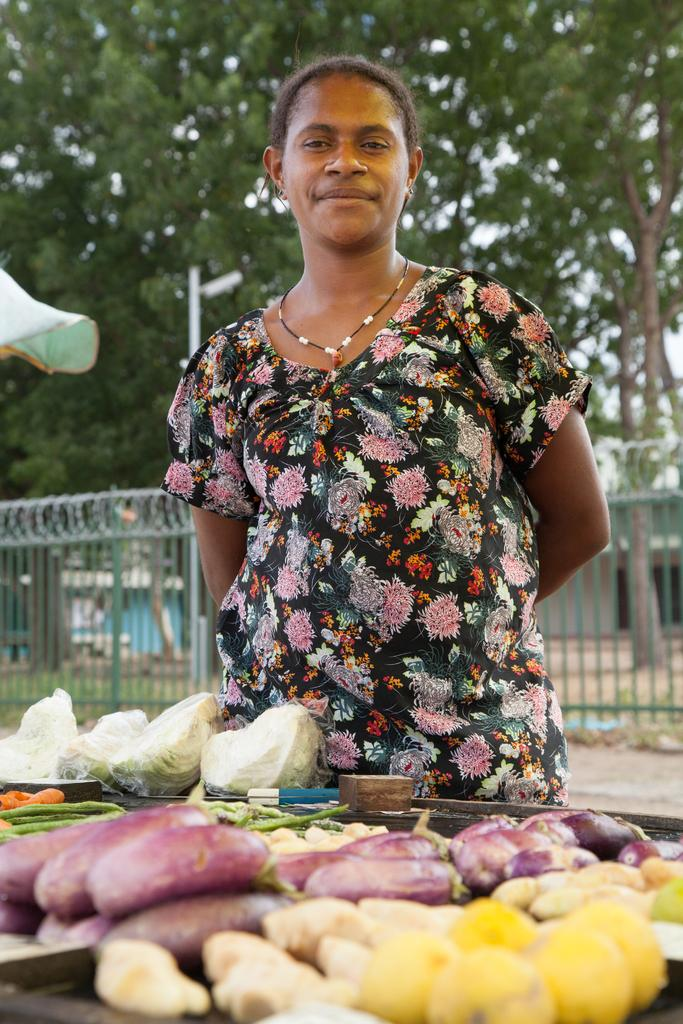Who is present in the image? There is a lady in the image. What is the lady doing in the image? The lady is standing with a smile on her face. What can be seen in front of the lady? There is a stall of vegetables in front of the lady. What is behind the lady? There is a railing, a building, and trees behind the lady. What other object is visible in the image? There is a pole visible in the image. What date is marked on the calendar in the image? There is no calendar present in the image. How many times does the lady sneeze in the image? The lady does not sneeze in the image; she is smiling. 